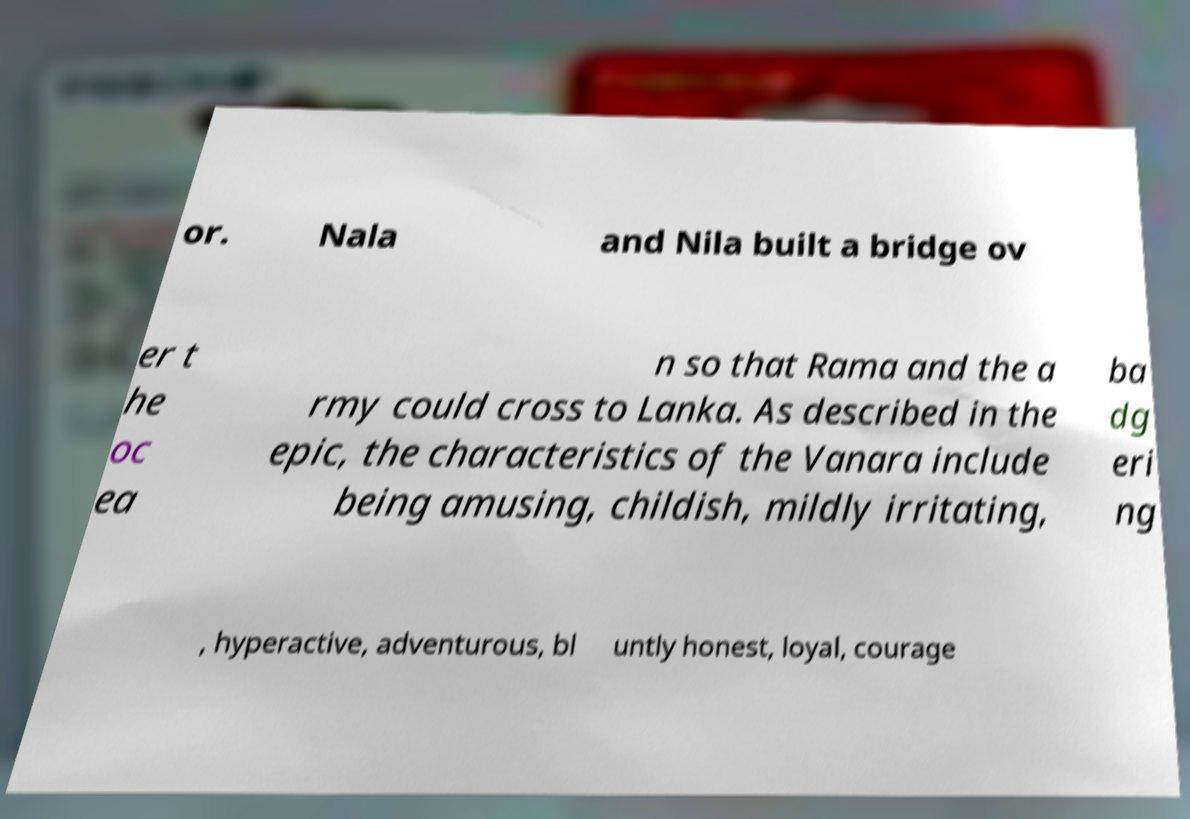There's text embedded in this image that I need extracted. Can you transcribe it verbatim? or. Nala and Nila built a bridge ov er t he oc ea n so that Rama and the a rmy could cross to Lanka. As described in the epic, the characteristics of the Vanara include being amusing, childish, mildly irritating, ba dg eri ng , hyperactive, adventurous, bl untly honest, loyal, courage 